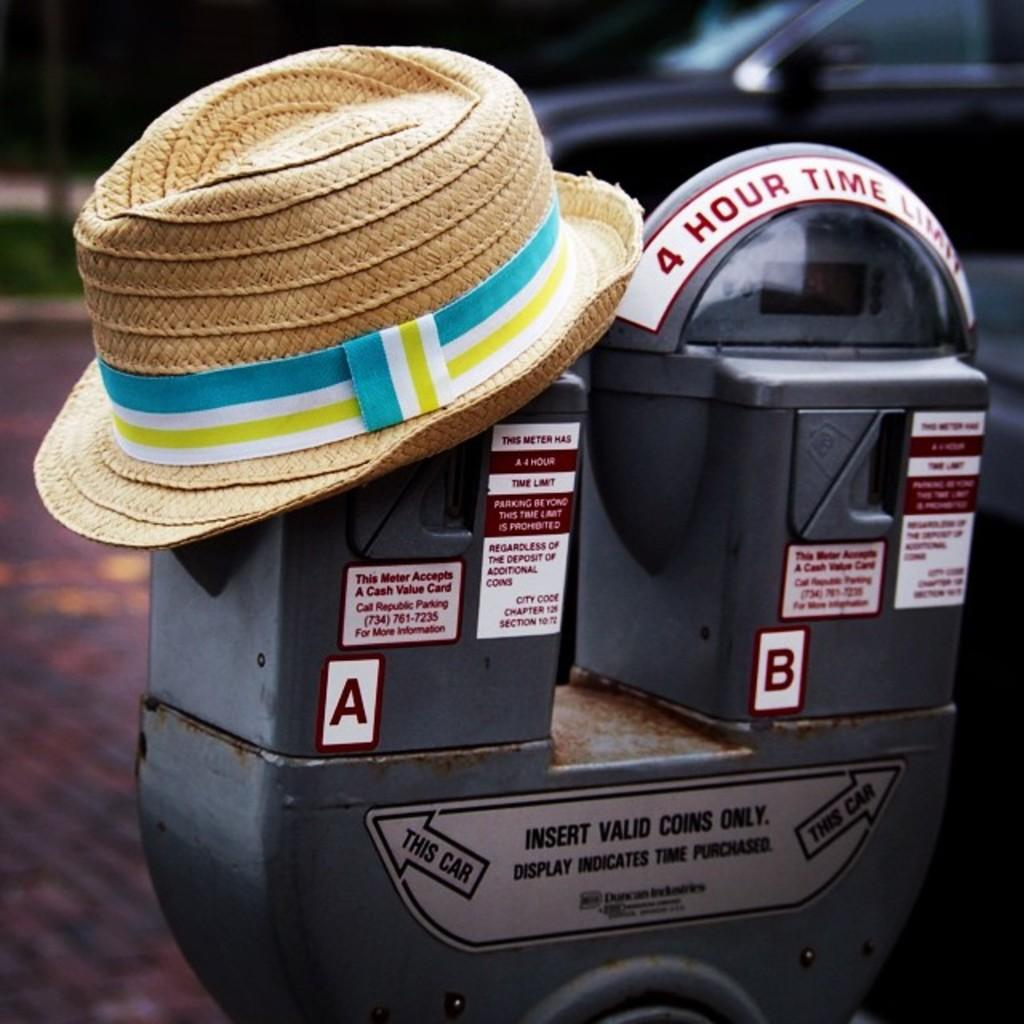<image>
Summarize the visual content of the image. Two parking meters, one with a hat on it and one that says 4 Hour Time Limit. 